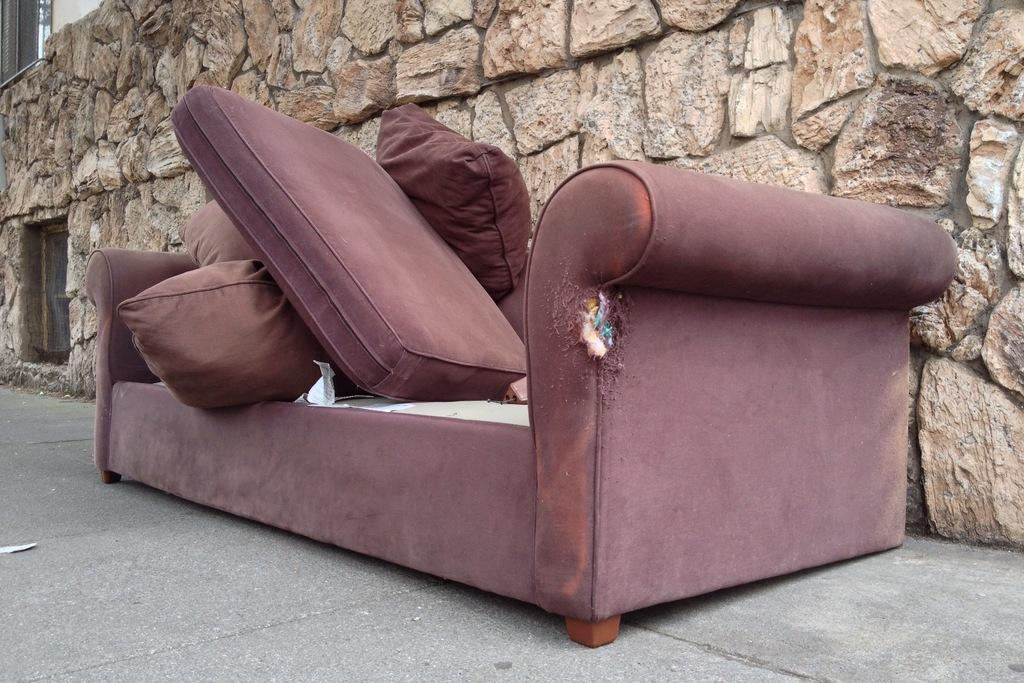What type of nerve can be seen in the image? There is no nerve visible in the image. Are there any books on the sofa in the image? There is no mention of books in the image. What might be the reason for placing the sofa on the road? The image does not provide information about the reason for placing the sofa on the road. What type of fear is depicted in the image? There is no fear depicted in the image; it features an old sofa with cushions on the road. 